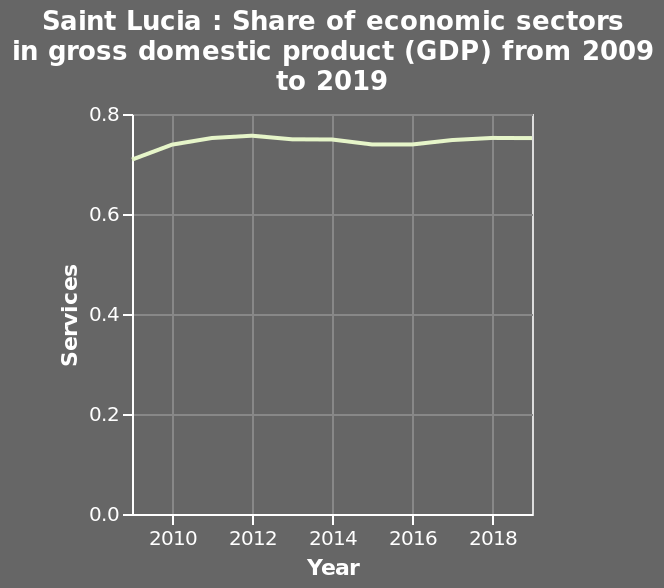<image>
please describe the details of the chart Here a line graph is labeled Saint Lucia : Share of economic sectors in gross domestic product (GDP) from 2009 to 2019. Year is shown along a linear scale of range 2010 to 2018 on the x-axis. There is a linear scale from 0.0 to 0.8 on the y-axis, labeled Services. Did GDP steadily increase or decrease between 2012 and the present on the graph? GDP steadily increased until 2012 before leveling out. What does the line graph represent? The line graph represents the share of economic sectors in Saint Lucia's gross domestic product (GDP) from 2009 to 2019. Offer a thorough analysis of the image. The graph indicates that share of economic sectors in GDP has remained relatively stable between 0.7 and 0.8 since 2012. GDP steadily increased until 2012 before levelling out, dropping slightly around 2015 but maintaining consistency. In the time shown on the chart, GDP has not dropped below 0.6 or exceeded 0.8. Is there a line graph labeled Saint Lucia: Share of economic sectors in gross domestic product (GDP) from 2019 to 2009? No.Here a line graph is labeled Saint Lucia : Share of economic sectors in gross domestic product (GDP) from 2009 to 2019. Year is shown along a linear scale of range 2010 to 2018 on the x-axis. There is a linear scale from 0.0 to 0.8 on the y-axis, labeled Services. 